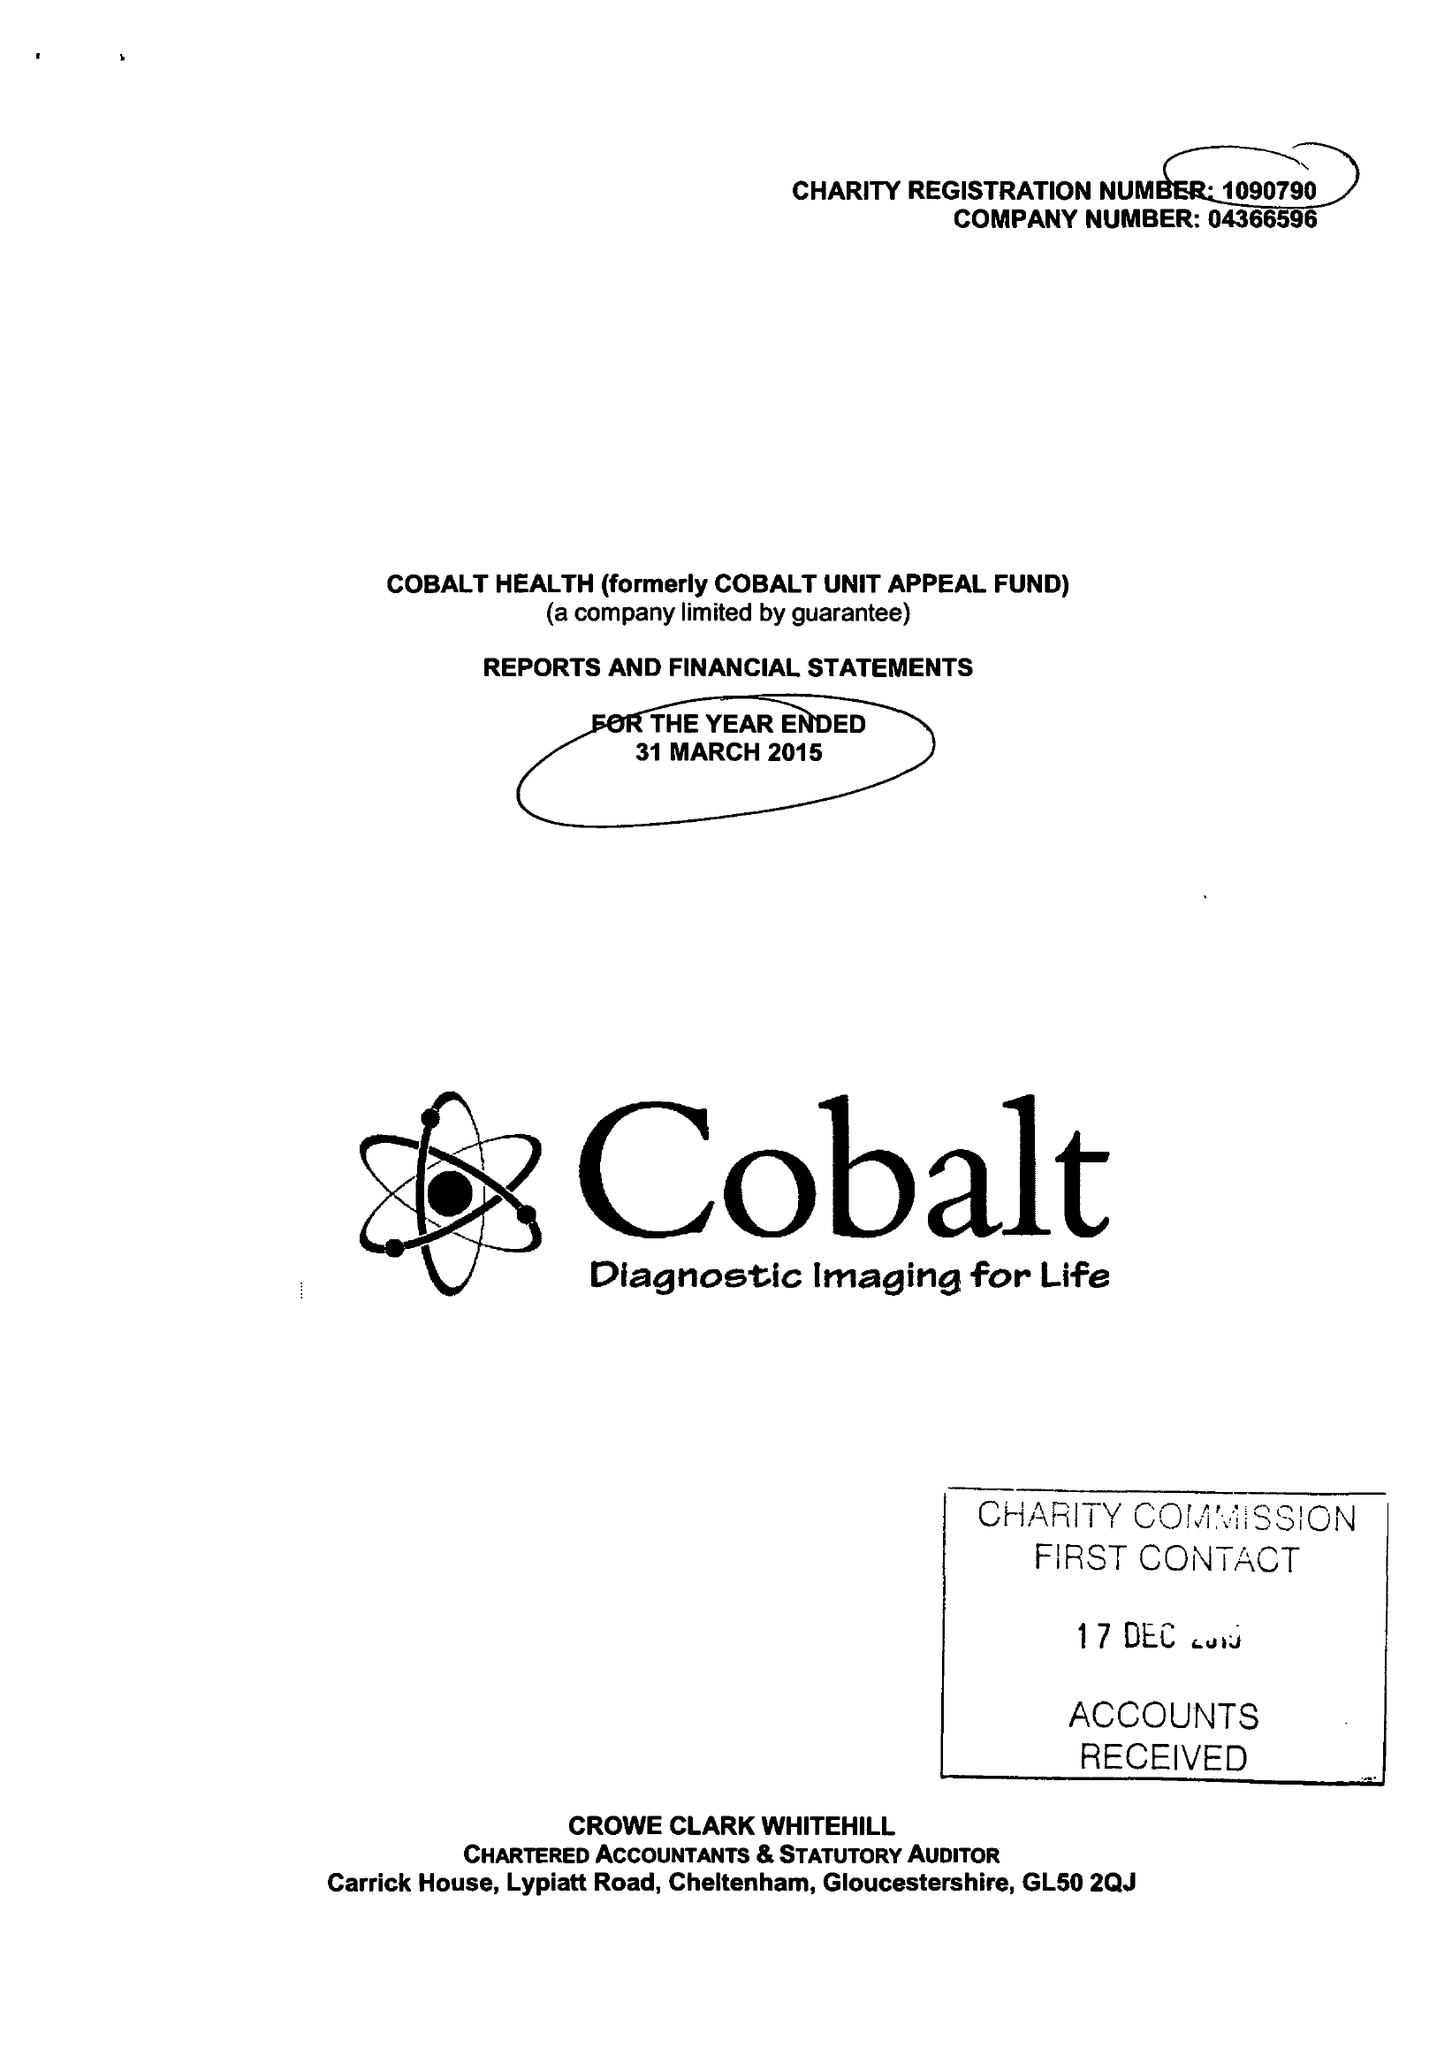What is the value for the address__post_town?
Answer the question using a single word or phrase. CHELTENHAM 